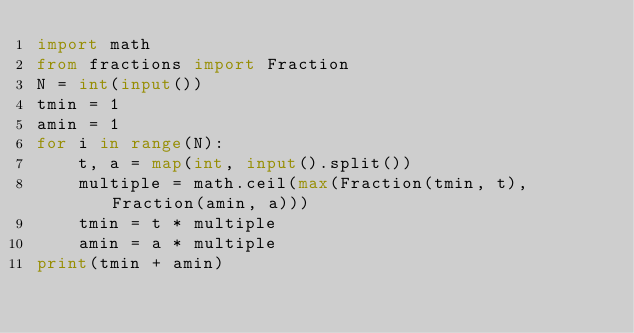Convert code to text. <code><loc_0><loc_0><loc_500><loc_500><_Python_>import math
from fractions import Fraction
N = int(input())
tmin = 1
amin = 1
for i in range(N):
    t, a = map(int, input().split())
    multiple = math.ceil(max(Fraction(tmin, t), Fraction(amin, a)))
    tmin = t * multiple
    amin = a * multiple
print(tmin + amin)</code> 